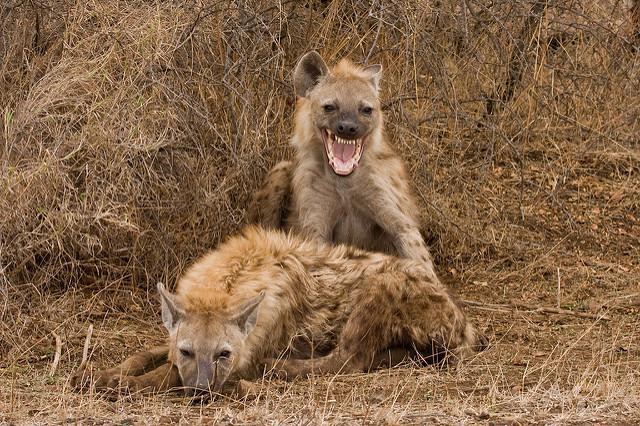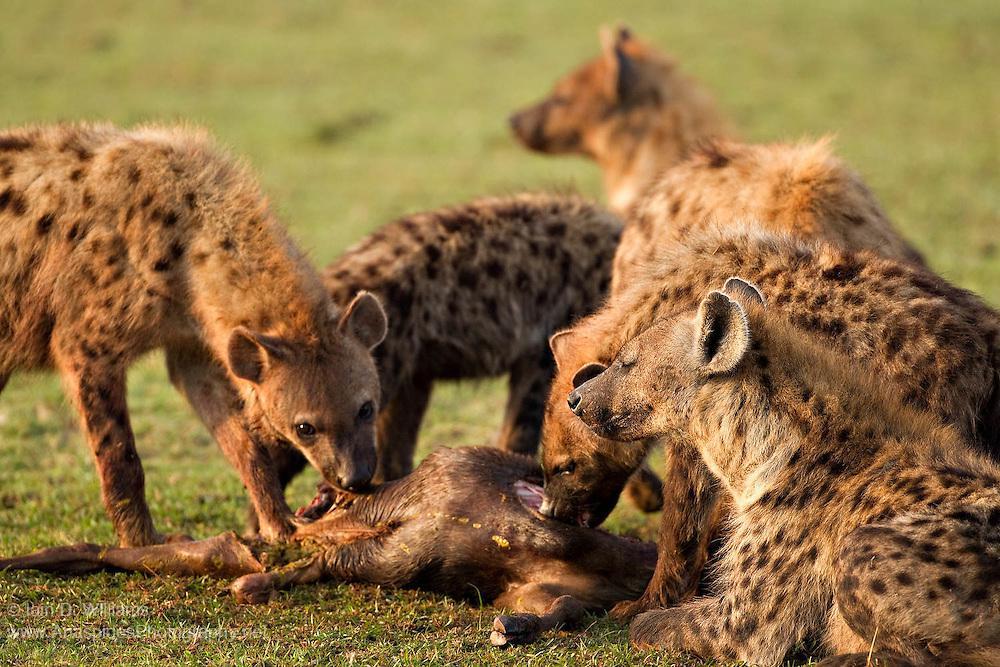The first image is the image on the left, the second image is the image on the right. Examine the images to the left and right. Is the description "An image shows one hyena, which is walking with at least part of an animal in its mouth." accurate? Answer yes or no. No. The first image is the image on the left, the second image is the image on the right. For the images displayed, is the sentence "The hyena in the image on the left is carrying a small animal in its mouth." factually correct? Answer yes or no. No. 